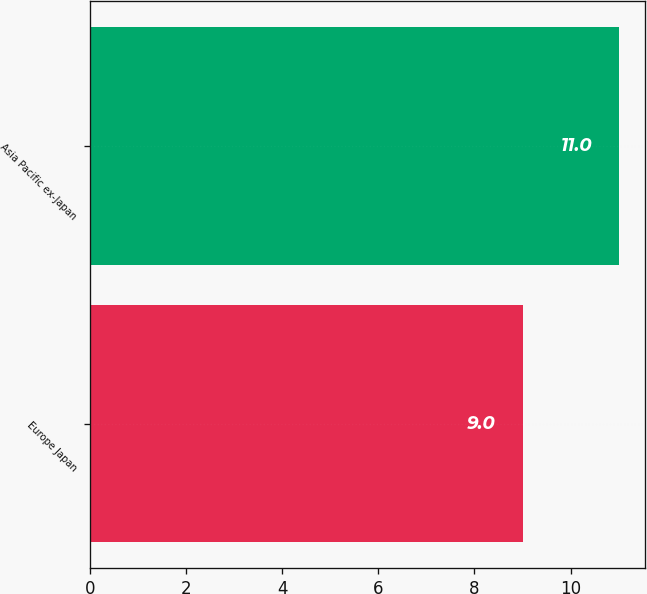<chart> <loc_0><loc_0><loc_500><loc_500><bar_chart><fcel>Europe Japan<fcel>Asia Pacific ex-Japan<nl><fcel>9<fcel>11<nl></chart> 